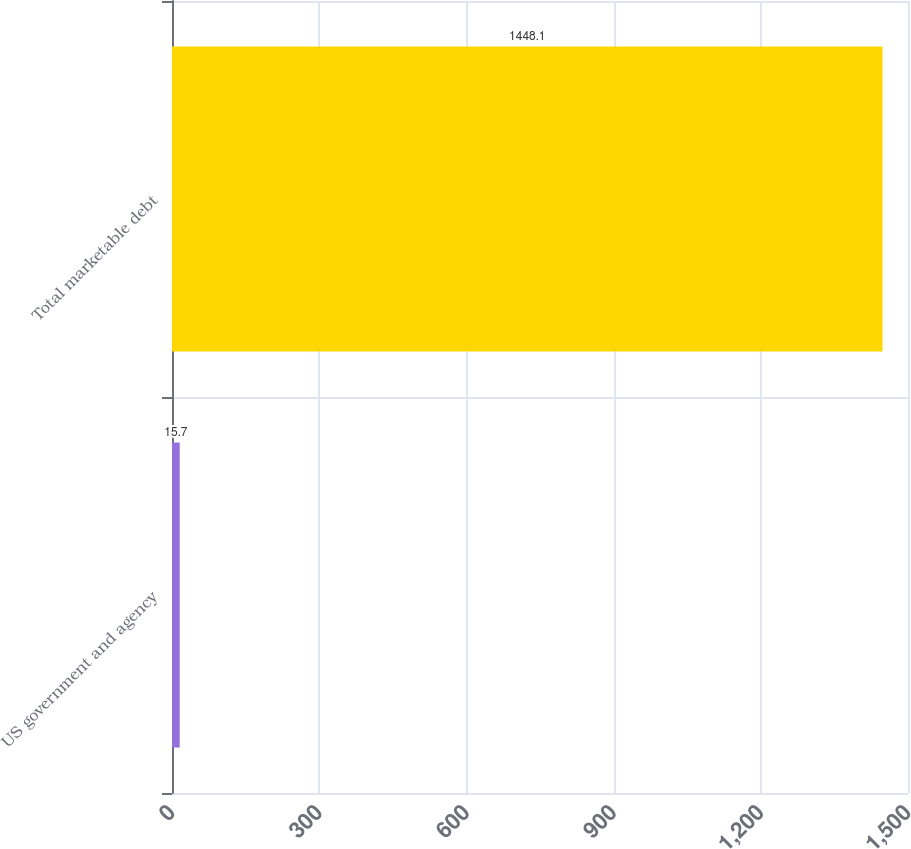Convert chart. <chart><loc_0><loc_0><loc_500><loc_500><bar_chart><fcel>US government and agency<fcel>Total marketable debt<nl><fcel>15.7<fcel>1448.1<nl></chart> 